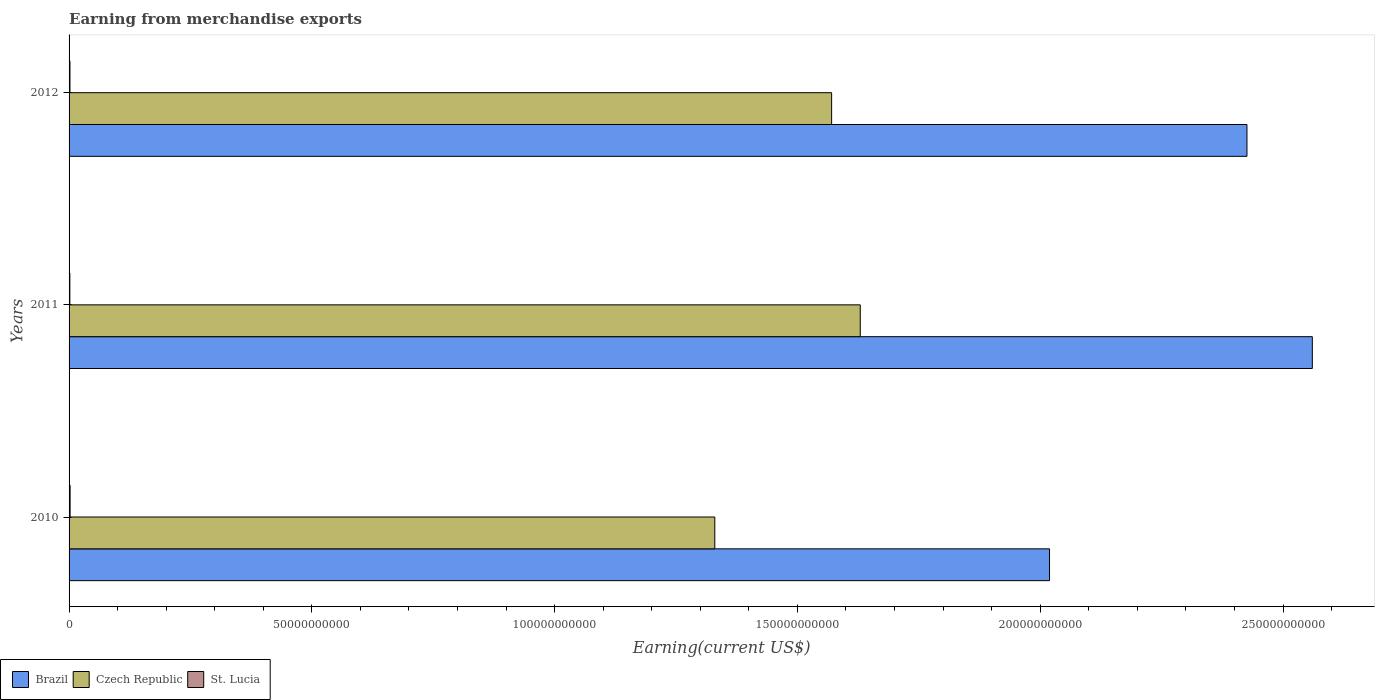How many groups of bars are there?
Ensure brevity in your answer.  3. Are the number of bars per tick equal to the number of legend labels?
Your answer should be very brief. Yes. How many bars are there on the 1st tick from the top?
Your answer should be very brief. 3. How many bars are there on the 1st tick from the bottom?
Provide a succinct answer. 3. What is the label of the 3rd group of bars from the top?
Keep it short and to the point. 2010. What is the amount earned from merchandise exports in Czech Republic in 2010?
Keep it short and to the point. 1.33e+11. Across all years, what is the maximum amount earned from merchandise exports in Brazil?
Give a very brief answer. 2.56e+11. Across all years, what is the minimum amount earned from merchandise exports in St. Lucia?
Your response must be concise. 1.60e+08. In which year was the amount earned from merchandise exports in Brazil maximum?
Provide a succinct answer. 2011. In which year was the amount earned from merchandise exports in Brazil minimum?
Your response must be concise. 2010. What is the total amount earned from merchandise exports in Czech Republic in the graph?
Ensure brevity in your answer.  4.53e+11. What is the difference between the amount earned from merchandise exports in St. Lucia in 2010 and that in 2012?
Keep it short and to the point. 3.21e+07. What is the difference between the amount earned from merchandise exports in Brazil in 2011 and the amount earned from merchandise exports in St. Lucia in 2012?
Provide a succinct answer. 2.56e+11. What is the average amount earned from merchandise exports in St. Lucia per year?
Offer a very short reply. 1.86e+08. In the year 2012, what is the difference between the amount earned from merchandise exports in Brazil and amount earned from merchandise exports in St. Lucia?
Give a very brief answer. 2.42e+11. What is the ratio of the amount earned from merchandise exports in St. Lucia in 2010 to that in 2012?
Ensure brevity in your answer.  1.18. Is the amount earned from merchandise exports in Czech Republic in 2010 less than that in 2011?
Provide a short and direct response. Yes. Is the difference between the amount earned from merchandise exports in Brazil in 2011 and 2012 greater than the difference between the amount earned from merchandise exports in St. Lucia in 2011 and 2012?
Give a very brief answer. Yes. What is the difference between the highest and the second highest amount earned from merchandise exports in Brazil?
Your response must be concise. 1.35e+1. What is the difference between the highest and the lowest amount earned from merchandise exports in Brazil?
Keep it short and to the point. 5.41e+1. What does the 1st bar from the bottom in 2012 represents?
Keep it short and to the point. Brazil. How many bars are there?
Provide a short and direct response. 9. Are the values on the major ticks of X-axis written in scientific E-notation?
Offer a terse response. No. How are the legend labels stacked?
Your response must be concise. Horizontal. What is the title of the graph?
Ensure brevity in your answer.  Earning from merchandise exports. Does "Israel" appear as one of the legend labels in the graph?
Your answer should be compact. No. What is the label or title of the X-axis?
Keep it short and to the point. Earning(current US$). What is the Earning(current US$) of Brazil in 2010?
Give a very brief answer. 2.02e+11. What is the Earning(current US$) of Czech Republic in 2010?
Give a very brief answer. 1.33e+11. What is the Earning(current US$) in St. Lucia in 2010?
Your answer should be compact. 2.15e+08. What is the Earning(current US$) in Brazil in 2011?
Offer a terse response. 2.56e+11. What is the Earning(current US$) of Czech Republic in 2011?
Ensure brevity in your answer.  1.63e+11. What is the Earning(current US$) of St. Lucia in 2011?
Make the answer very short. 1.60e+08. What is the Earning(current US$) of Brazil in 2012?
Your answer should be compact. 2.43e+11. What is the Earning(current US$) of Czech Republic in 2012?
Make the answer very short. 1.57e+11. What is the Earning(current US$) of St. Lucia in 2012?
Offer a terse response. 1.82e+08. Across all years, what is the maximum Earning(current US$) of Brazil?
Give a very brief answer. 2.56e+11. Across all years, what is the maximum Earning(current US$) of Czech Republic?
Make the answer very short. 1.63e+11. Across all years, what is the maximum Earning(current US$) in St. Lucia?
Keep it short and to the point. 2.15e+08. Across all years, what is the minimum Earning(current US$) of Brazil?
Your response must be concise. 2.02e+11. Across all years, what is the minimum Earning(current US$) of Czech Republic?
Provide a succinct answer. 1.33e+11. Across all years, what is the minimum Earning(current US$) in St. Lucia?
Ensure brevity in your answer.  1.60e+08. What is the total Earning(current US$) in Brazil in the graph?
Your answer should be compact. 7.01e+11. What is the total Earning(current US$) of Czech Republic in the graph?
Offer a terse response. 4.53e+11. What is the total Earning(current US$) of St. Lucia in the graph?
Offer a very short reply. 5.57e+08. What is the difference between the Earning(current US$) of Brazil in 2010 and that in 2011?
Your answer should be compact. -5.41e+1. What is the difference between the Earning(current US$) in Czech Republic in 2010 and that in 2011?
Your answer should be very brief. -3.00e+1. What is the difference between the Earning(current US$) of St. Lucia in 2010 and that in 2011?
Make the answer very short. 5.44e+07. What is the difference between the Earning(current US$) of Brazil in 2010 and that in 2012?
Your answer should be very brief. -4.07e+1. What is the difference between the Earning(current US$) of Czech Republic in 2010 and that in 2012?
Give a very brief answer. -2.41e+1. What is the difference between the Earning(current US$) of St. Lucia in 2010 and that in 2012?
Keep it short and to the point. 3.21e+07. What is the difference between the Earning(current US$) of Brazil in 2011 and that in 2012?
Provide a succinct answer. 1.35e+1. What is the difference between the Earning(current US$) in Czech Republic in 2011 and that in 2012?
Offer a terse response. 5.90e+09. What is the difference between the Earning(current US$) in St. Lucia in 2011 and that in 2012?
Ensure brevity in your answer.  -2.23e+07. What is the difference between the Earning(current US$) of Brazil in 2010 and the Earning(current US$) of Czech Republic in 2011?
Keep it short and to the point. 3.90e+1. What is the difference between the Earning(current US$) in Brazil in 2010 and the Earning(current US$) in St. Lucia in 2011?
Make the answer very short. 2.02e+11. What is the difference between the Earning(current US$) of Czech Republic in 2010 and the Earning(current US$) of St. Lucia in 2011?
Make the answer very short. 1.33e+11. What is the difference between the Earning(current US$) of Brazil in 2010 and the Earning(current US$) of Czech Republic in 2012?
Keep it short and to the point. 4.49e+1. What is the difference between the Earning(current US$) of Brazil in 2010 and the Earning(current US$) of St. Lucia in 2012?
Make the answer very short. 2.02e+11. What is the difference between the Earning(current US$) in Czech Republic in 2010 and the Earning(current US$) in St. Lucia in 2012?
Your answer should be compact. 1.33e+11. What is the difference between the Earning(current US$) of Brazil in 2011 and the Earning(current US$) of Czech Republic in 2012?
Your response must be concise. 9.90e+1. What is the difference between the Earning(current US$) of Brazil in 2011 and the Earning(current US$) of St. Lucia in 2012?
Offer a very short reply. 2.56e+11. What is the difference between the Earning(current US$) of Czech Republic in 2011 and the Earning(current US$) of St. Lucia in 2012?
Provide a short and direct response. 1.63e+11. What is the average Earning(current US$) of Brazil per year?
Your answer should be very brief. 2.34e+11. What is the average Earning(current US$) of Czech Republic per year?
Make the answer very short. 1.51e+11. What is the average Earning(current US$) of St. Lucia per year?
Offer a very short reply. 1.86e+08. In the year 2010, what is the difference between the Earning(current US$) of Brazil and Earning(current US$) of Czech Republic?
Keep it short and to the point. 6.89e+1. In the year 2010, what is the difference between the Earning(current US$) in Brazil and Earning(current US$) in St. Lucia?
Make the answer very short. 2.02e+11. In the year 2010, what is the difference between the Earning(current US$) in Czech Republic and Earning(current US$) in St. Lucia?
Offer a terse response. 1.33e+11. In the year 2011, what is the difference between the Earning(current US$) of Brazil and Earning(current US$) of Czech Republic?
Your response must be concise. 9.31e+1. In the year 2011, what is the difference between the Earning(current US$) of Brazil and Earning(current US$) of St. Lucia?
Make the answer very short. 2.56e+11. In the year 2011, what is the difference between the Earning(current US$) in Czech Republic and Earning(current US$) in St. Lucia?
Keep it short and to the point. 1.63e+11. In the year 2012, what is the difference between the Earning(current US$) of Brazil and Earning(current US$) of Czech Republic?
Your answer should be very brief. 8.55e+1. In the year 2012, what is the difference between the Earning(current US$) of Brazil and Earning(current US$) of St. Lucia?
Provide a succinct answer. 2.42e+11. In the year 2012, what is the difference between the Earning(current US$) of Czech Republic and Earning(current US$) of St. Lucia?
Provide a short and direct response. 1.57e+11. What is the ratio of the Earning(current US$) in Brazil in 2010 to that in 2011?
Give a very brief answer. 0.79. What is the ratio of the Earning(current US$) of Czech Republic in 2010 to that in 2011?
Offer a very short reply. 0.82. What is the ratio of the Earning(current US$) of St. Lucia in 2010 to that in 2011?
Keep it short and to the point. 1.34. What is the ratio of the Earning(current US$) in Brazil in 2010 to that in 2012?
Your answer should be compact. 0.83. What is the ratio of the Earning(current US$) of Czech Republic in 2010 to that in 2012?
Provide a short and direct response. 0.85. What is the ratio of the Earning(current US$) in St. Lucia in 2010 to that in 2012?
Your response must be concise. 1.18. What is the ratio of the Earning(current US$) of Brazil in 2011 to that in 2012?
Provide a succinct answer. 1.06. What is the ratio of the Earning(current US$) of Czech Republic in 2011 to that in 2012?
Keep it short and to the point. 1.04. What is the ratio of the Earning(current US$) of St. Lucia in 2011 to that in 2012?
Your answer should be compact. 0.88. What is the difference between the highest and the second highest Earning(current US$) of Brazil?
Provide a short and direct response. 1.35e+1. What is the difference between the highest and the second highest Earning(current US$) of Czech Republic?
Provide a short and direct response. 5.90e+09. What is the difference between the highest and the second highest Earning(current US$) of St. Lucia?
Make the answer very short. 3.21e+07. What is the difference between the highest and the lowest Earning(current US$) of Brazil?
Your response must be concise. 5.41e+1. What is the difference between the highest and the lowest Earning(current US$) of Czech Republic?
Offer a very short reply. 3.00e+1. What is the difference between the highest and the lowest Earning(current US$) in St. Lucia?
Provide a succinct answer. 5.44e+07. 